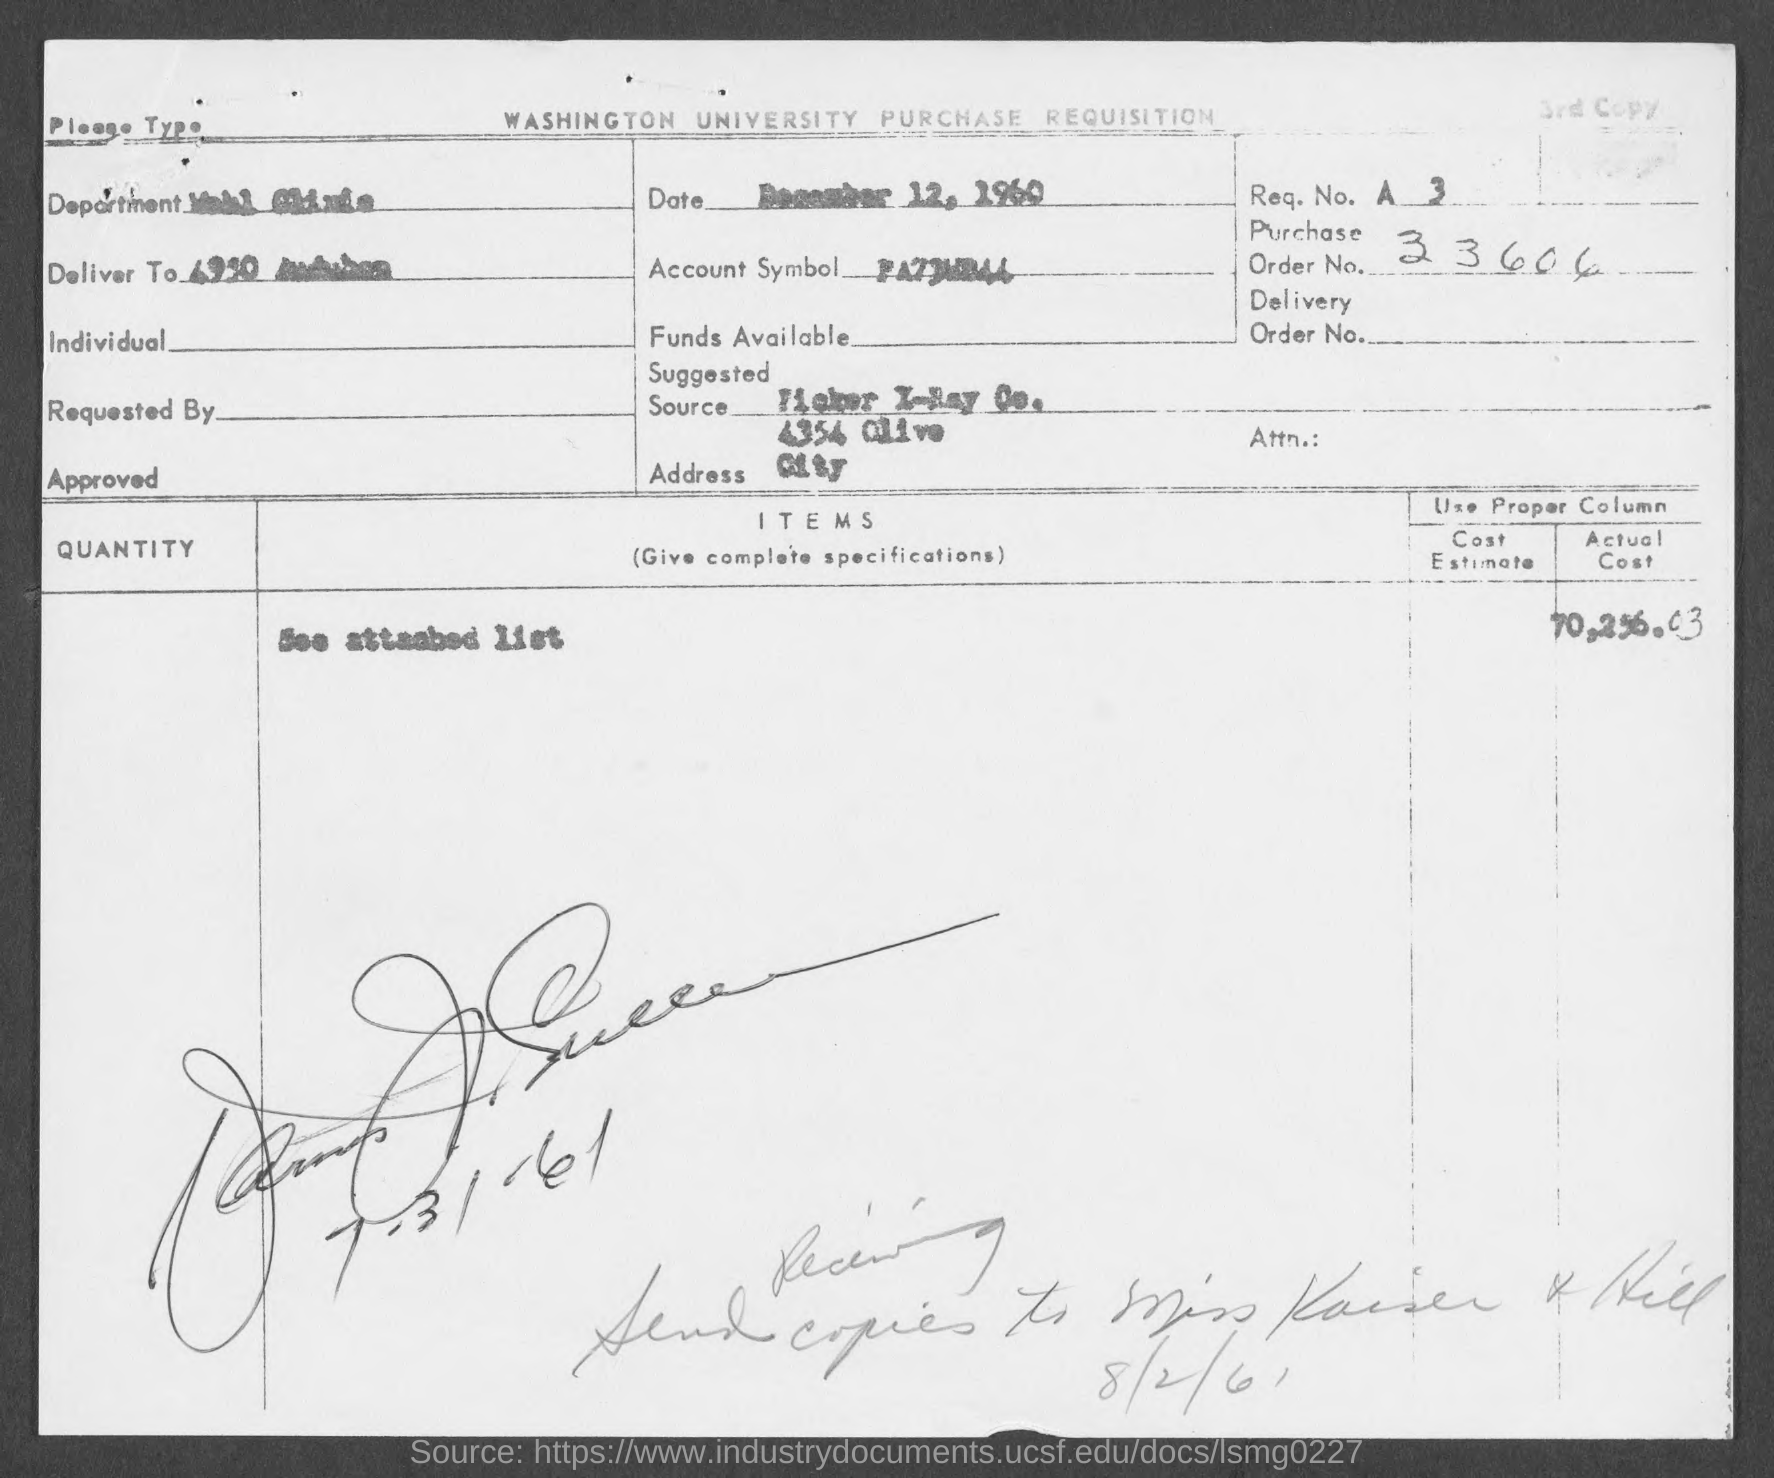What is the purchase order no.?
Your answer should be very brief. 33606. 